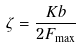Convert formula to latex. <formula><loc_0><loc_0><loc_500><loc_500>\zeta = \frac { K b } { 2 F _ { \max } }</formula> 